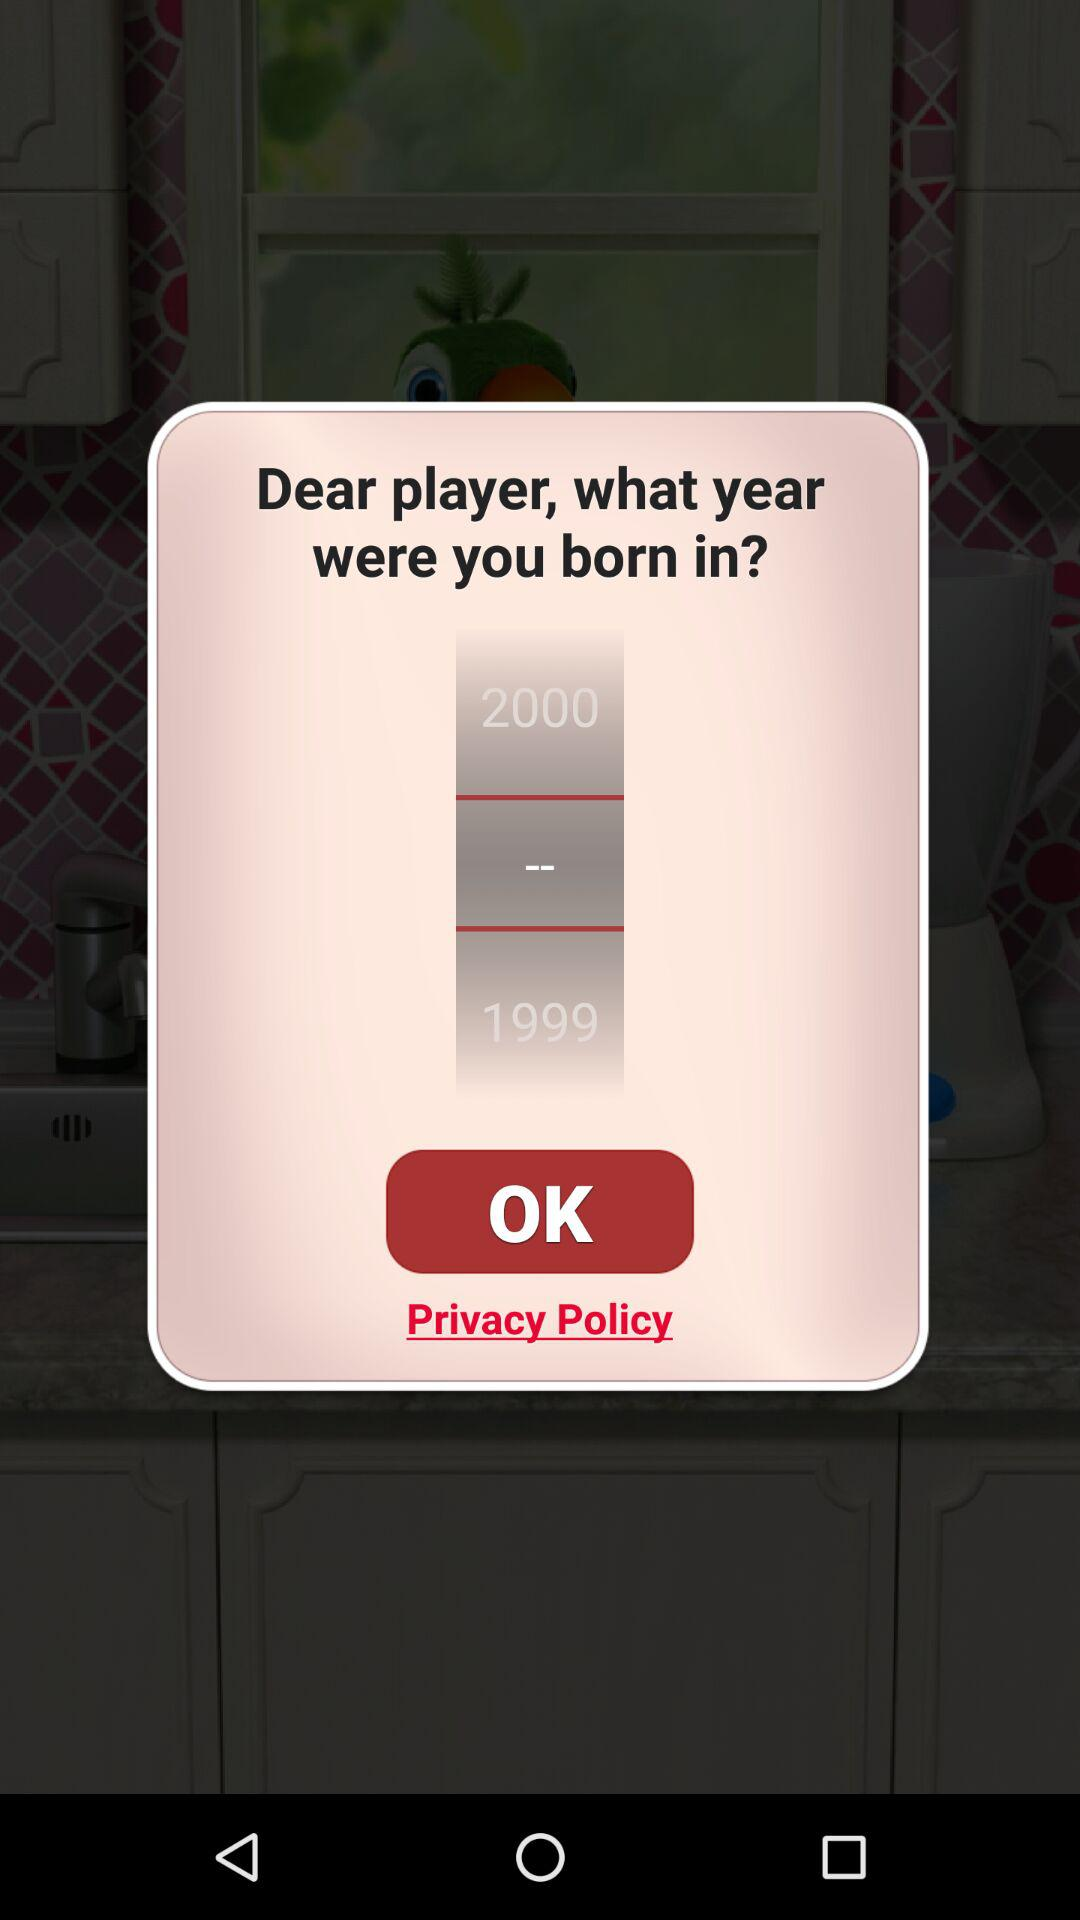How many years older is the year 2000 than the year 1999?
Answer the question using a single word or phrase. 1 